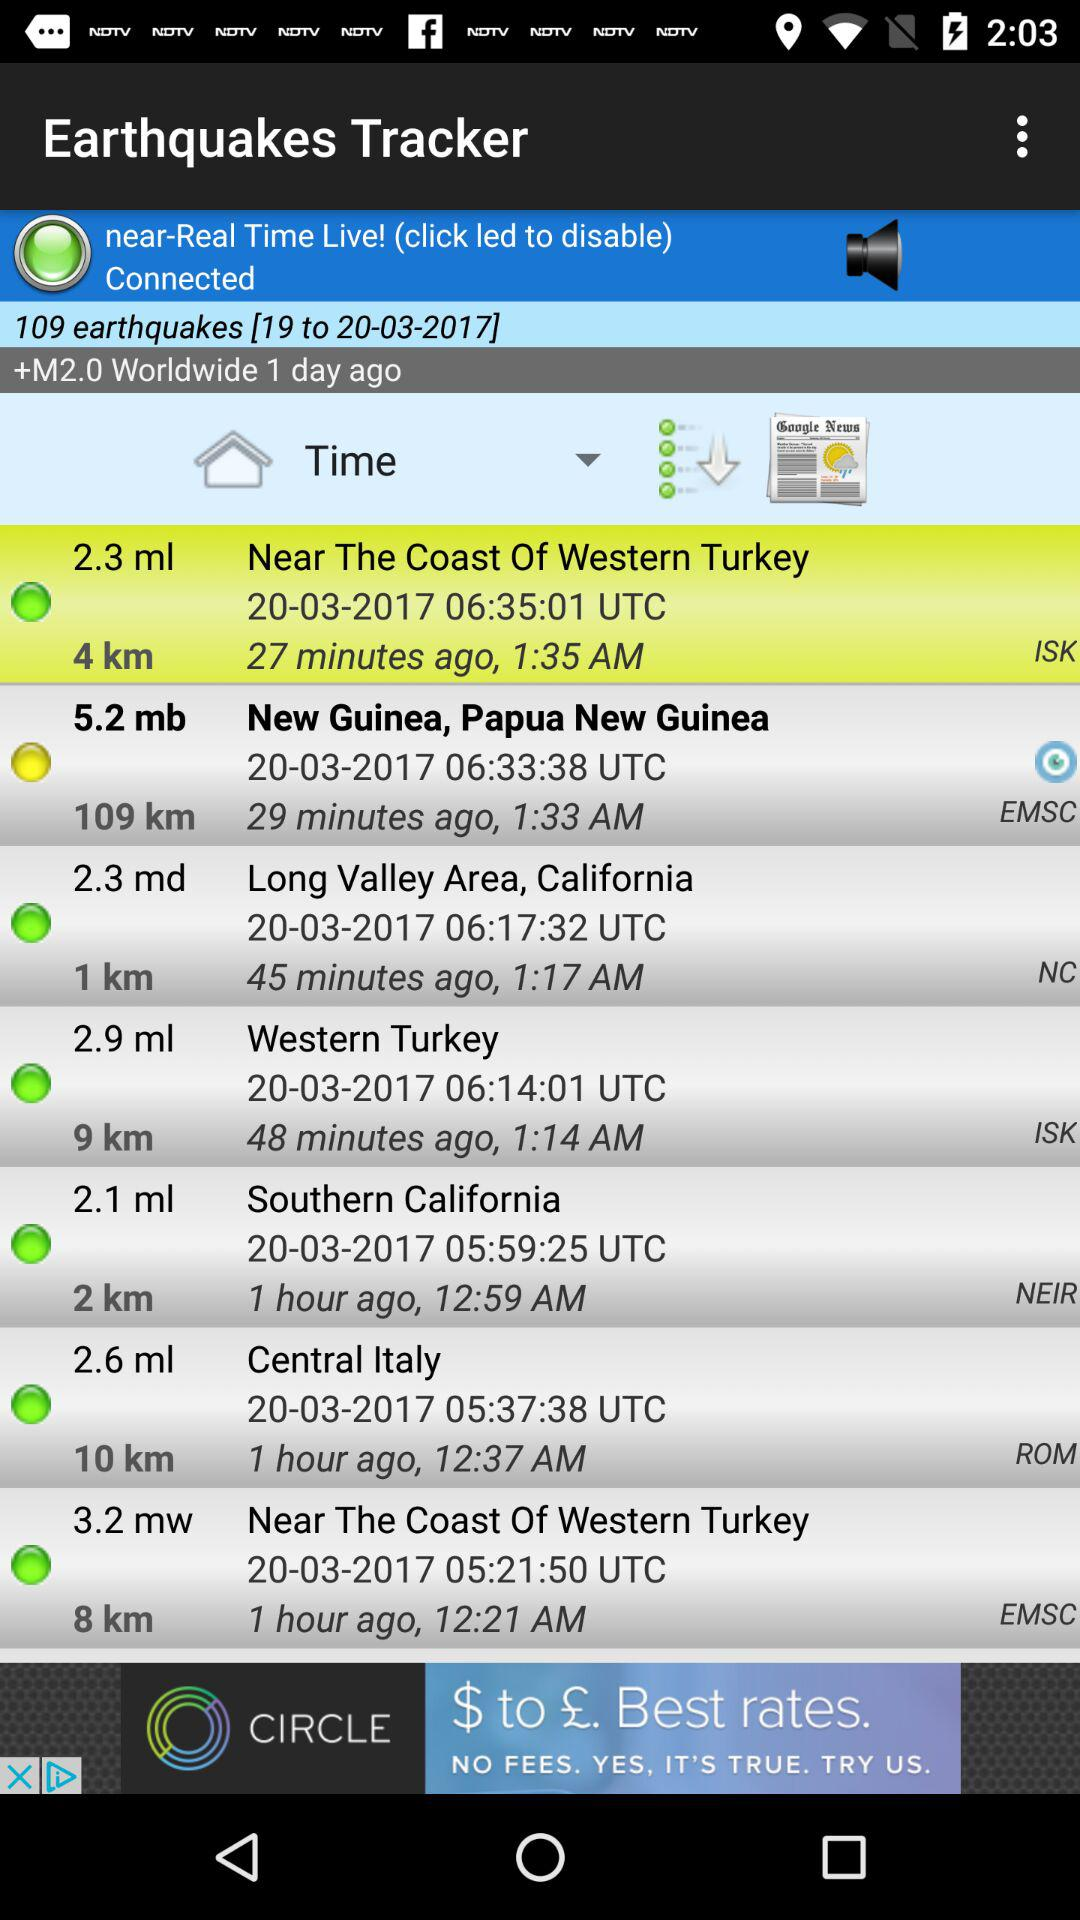What is the user's name?
When the provided information is insufficient, respond with <no answer>. <no answer> 